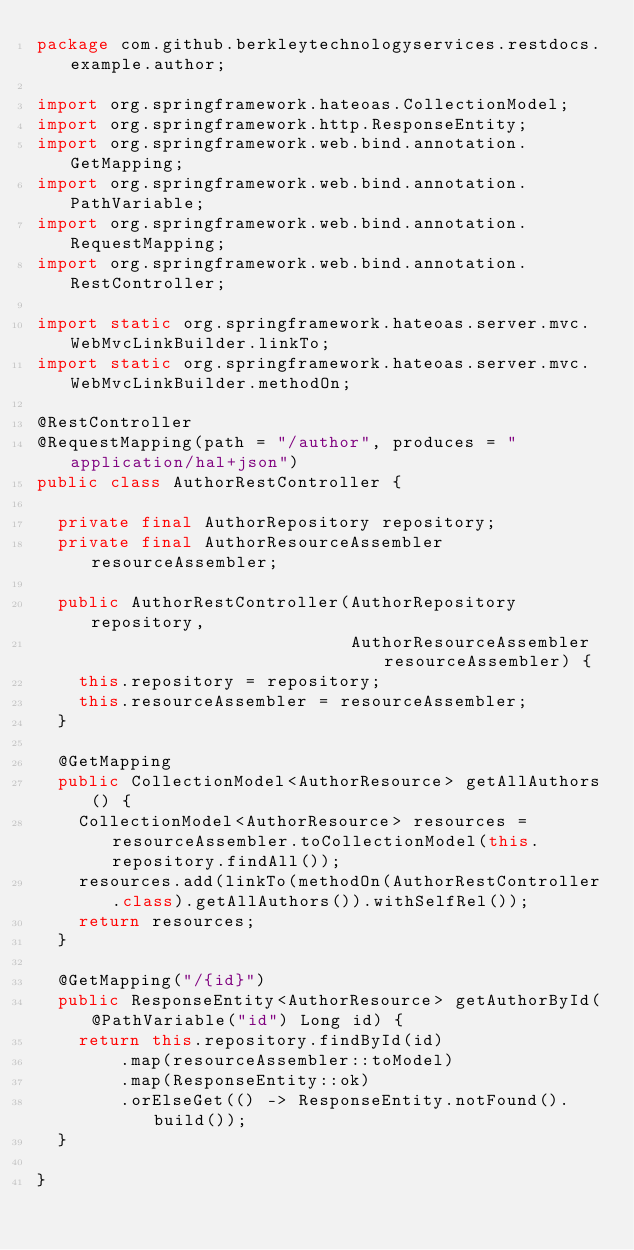<code> <loc_0><loc_0><loc_500><loc_500><_Java_>package com.github.berkleytechnologyservices.restdocs.example.author;

import org.springframework.hateoas.CollectionModel;
import org.springframework.http.ResponseEntity;
import org.springframework.web.bind.annotation.GetMapping;
import org.springframework.web.bind.annotation.PathVariable;
import org.springframework.web.bind.annotation.RequestMapping;
import org.springframework.web.bind.annotation.RestController;

import static org.springframework.hateoas.server.mvc.WebMvcLinkBuilder.linkTo;
import static org.springframework.hateoas.server.mvc.WebMvcLinkBuilder.methodOn;

@RestController
@RequestMapping(path = "/author", produces = "application/hal+json")
public class AuthorRestController {

  private final AuthorRepository repository;
  private final AuthorResourceAssembler resourceAssembler;

  public AuthorRestController(AuthorRepository repository,
                              AuthorResourceAssembler resourceAssembler) {
    this.repository = repository;
    this.resourceAssembler = resourceAssembler;
  }

  @GetMapping
  public CollectionModel<AuthorResource> getAllAuthors() {
    CollectionModel<AuthorResource> resources = resourceAssembler.toCollectionModel(this.repository.findAll());
    resources.add(linkTo(methodOn(AuthorRestController.class).getAllAuthors()).withSelfRel());
    return resources;
  }

  @GetMapping("/{id}")
  public ResponseEntity<AuthorResource> getAuthorById(@PathVariable("id") Long id) {
    return this.repository.findById(id)
        .map(resourceAssembler::toModel)
        .map(ResponseEntity::ok)
        .orElseGet(() -> ResponseEntity.notFound().build());
  }

}
</code> 